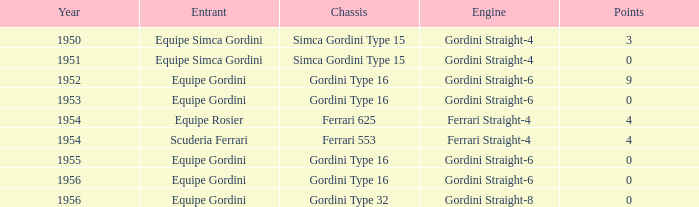What motor was utilized by equipe simca gordini prior to 1956 with under 4 points? Gordini Straight-4, Gordini Straight-4. 